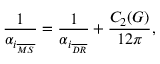Convert formula to latex. <formula><loc_0><loc_0><loc_500><loc_500>\frac { 1 } { \alpha _ { i _ { \overline { M S } } } } = \frac { 1 } { \alpha _ { i _ { \overline { D R } } } } + \frac { C _ { 2 } ( G ) } { 1 2 \pi } ,</formula> 